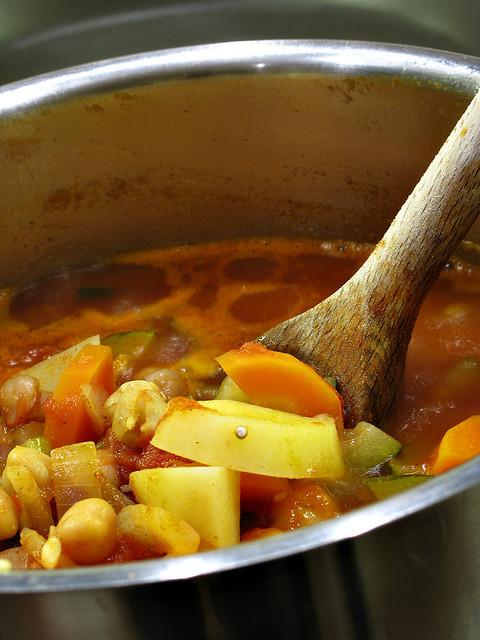Is this a vegetable soup?
Concise answer only. Yes. What is in the pot?
Answer briefly. Stew. What material is the spoon made from?
Give a very brief answer. Wood. 